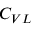<formula> <loc_0><loc_0><loc_500><loc_500>C _ { V L }</formula> 